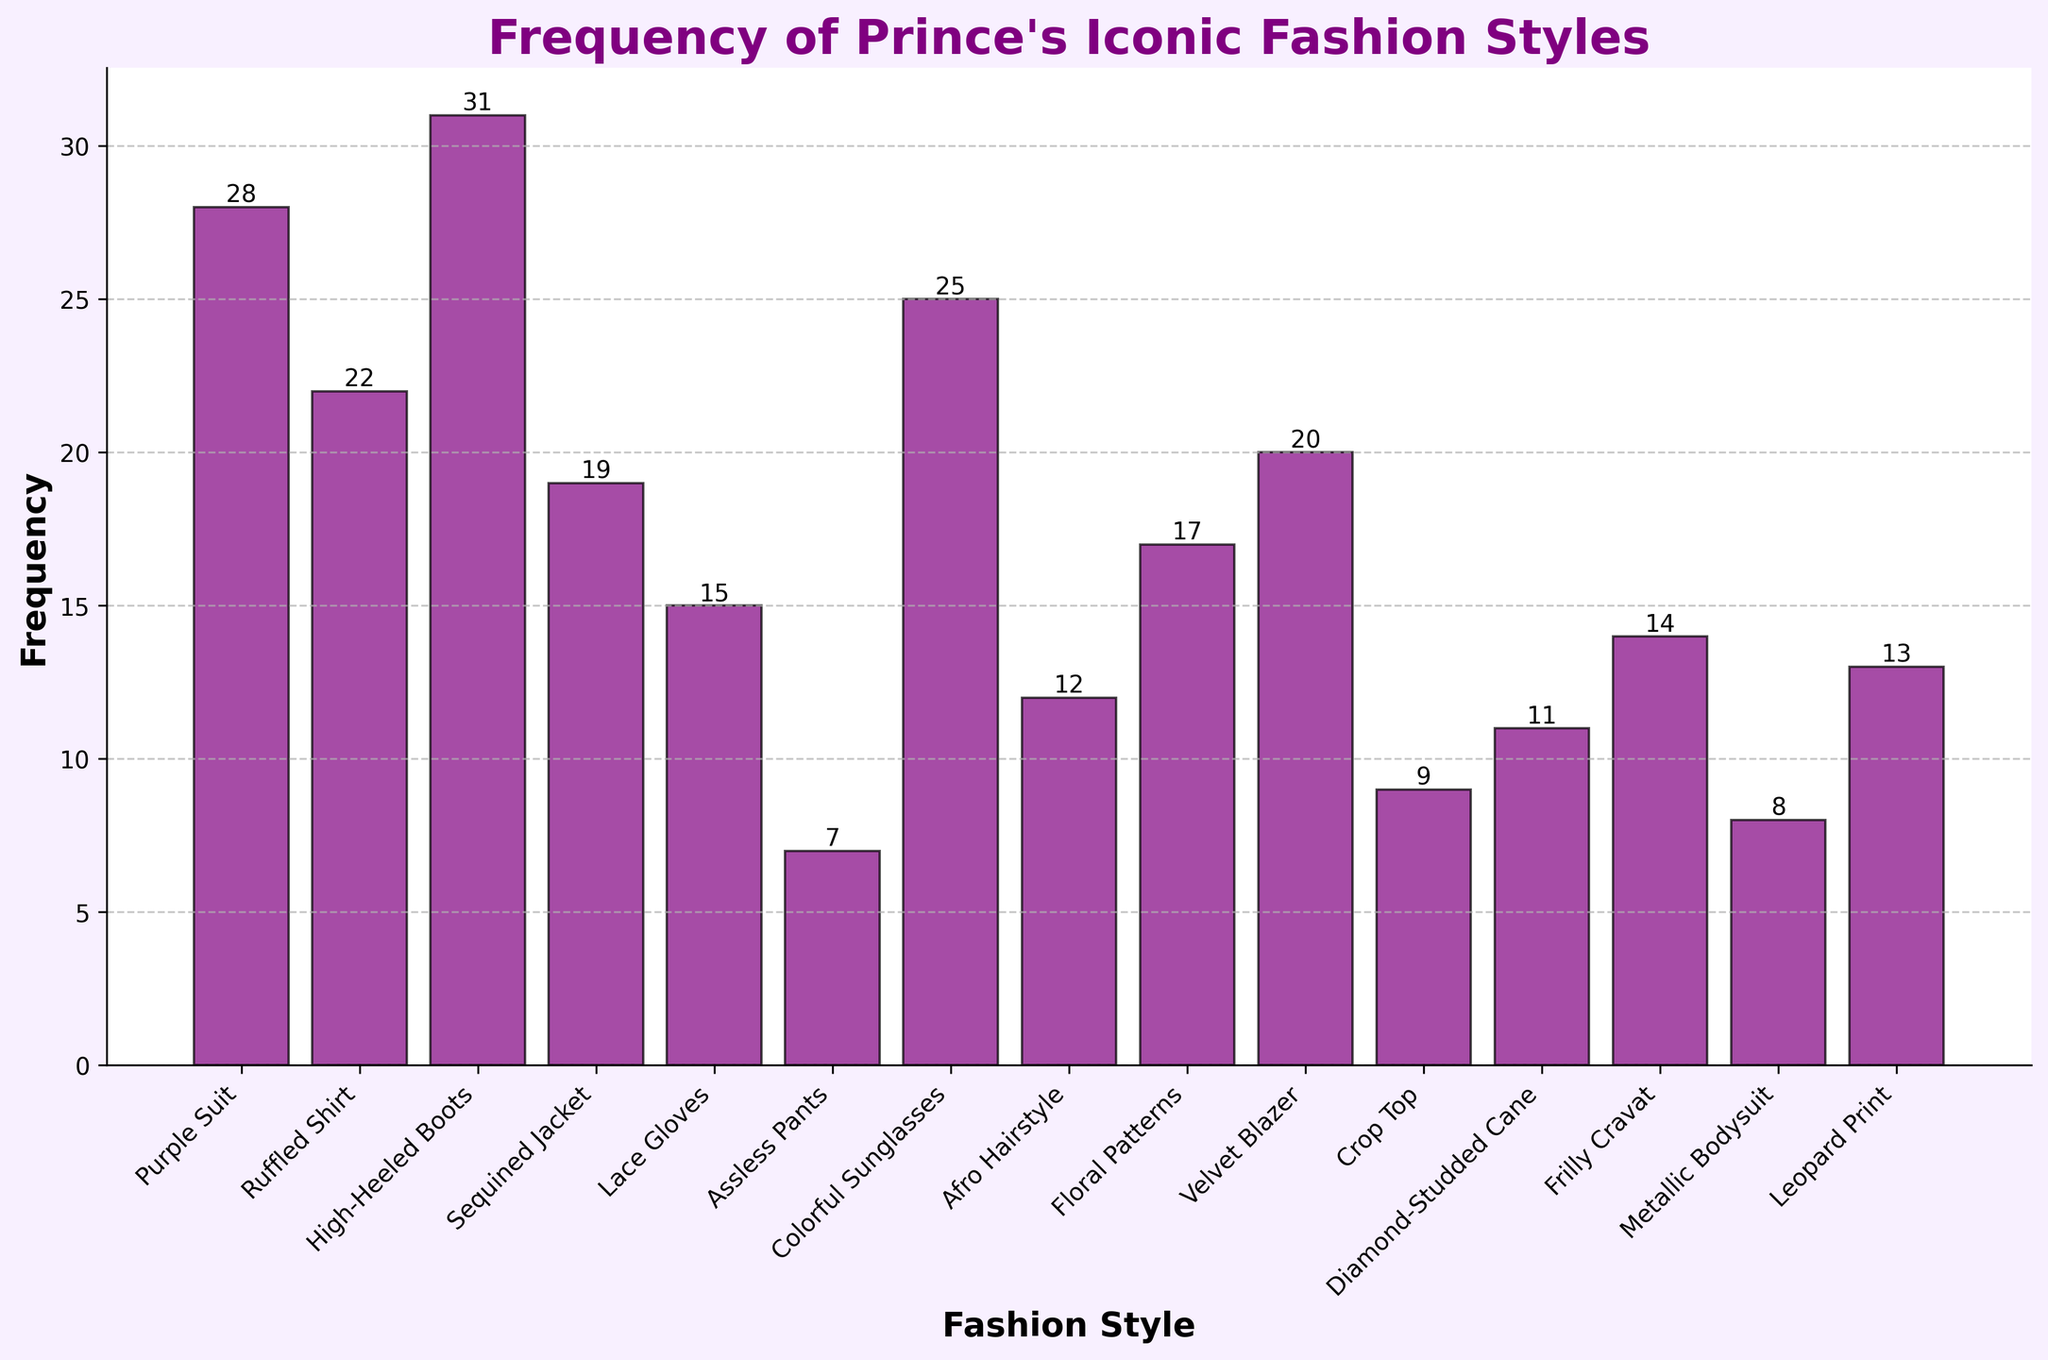What fashion style has the highest frequency? The highest bar in the chart represents the "High-Heeled Boots" style, indicating that it has the highest frequency at 31.
Answer: High-Heeled Boots Which has a higher frequency: "Purple Suit" or "Colorful Sunglasses"? By comparing the bars on the chart, "Purple Suit" has a frequency of 28, while "Colorful Sunglasses" has a frequency of 25. Thus, "Purple Suit" has a higher frequency.
Answer: Purple Suit What is the difference in frequency between the "Assless Pants" and "Sequined Jacket" styles? "Assless Pants" has a frequency of 7 and "Sequined Jacket" has a frequency of 19. The difference is 19 - 7 = 12.
Answer: 12 How many styles have a frequency greater than 20? By visually inspecting the chart, three styles ("Purple Suit", "High-Heeled Boots", and "Colorful Sunglasses") have frequencies greater than 20.
Answer: 3 What is the sum of the frequencies of "Lace Gloves" and "Floral Patterns"? "Lace Gloves" has a frequency of 15 and "Floral Patterns" has a frequency of 17. The sum is 15 + 17 = 32.
Answer: 32 What's the average frequency of "Ruffled Shirt", "Afro Hairstyle", and "Leopard Print"? The frequencies are 22 for "Ruffled Shirt", 12 for "Afro Hairstyle", and 13 for "Leopard Print". The sum is 22 + 12 + 13 = 47, and the average is 47 / 3 ≈ 15.67.
Answer: 15.67 Between "Metallic Bodysuit" and "Frilly Cravat," which style has the lower frequency, and what is the difference? "Metallic Bodysuit" has a frequency of 8, and "Frilly Cravat" has a frequency of 14. "Metallic Bodysuit" is lower, with a difference of 14 - 8 = 6.
Answer: Metallic Bodysuit, 6 Is the frequency of the "Diamond-Studded Cane" higher or lower than the average frequency of all styles combined? First, calculate the total sum of all frequencies: 28 + 22 + 31 + 19 + 15 + 7 + 25 + 12 + 17 + 20 + 9 + 11 + 14 + 8 + 13 = 251. There are 15 styles, so the average is 251 / 15 ≈ 16.73. The "Diamond-Studded Cane" has a frequency of 11, which is lower than the average of 16.73.
Answer: Lower Which style marks the midpoint frequency value when all are ordered? (Median) Order the frequencies: 7, 8, 9, 11, 12, 13, 14, 15, 17, 19, 20, 22, 25, 28, 31. The median value, being the middle value in the sorted list, is 15, corresponding to "Lace Gloves."
Answer: Lace Gloves 